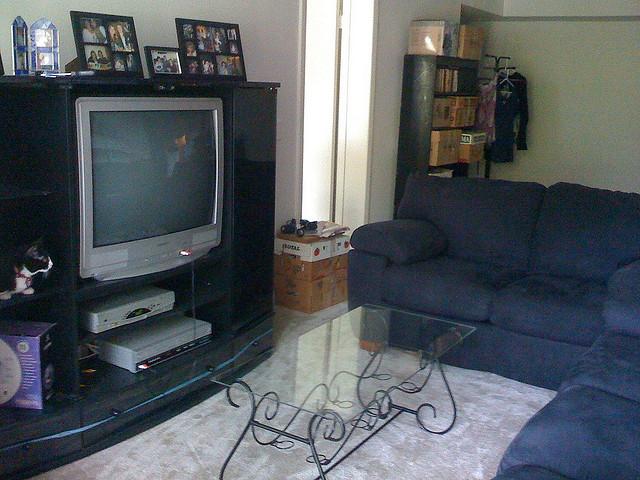How big is the TV?
Concise answer only. 28 inches. What color is the sofa?
Concise answer only. Blue. Where is the TV?
Short answer required. Living room. 